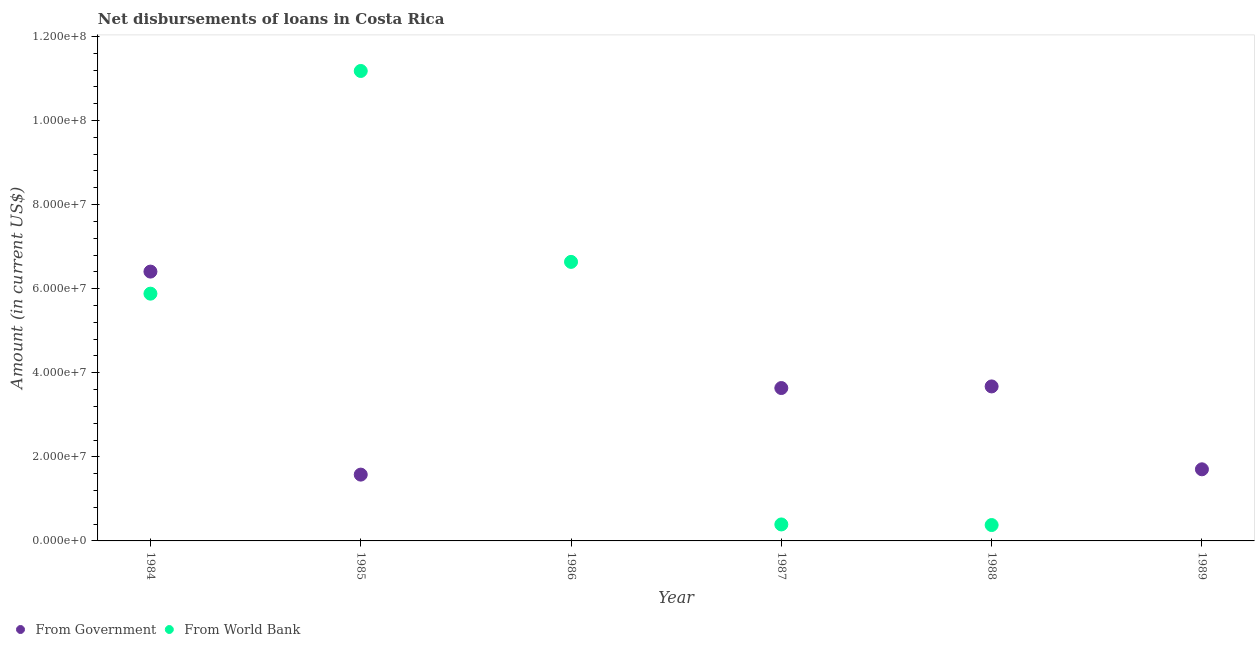What is the net disbursements of loan from government in 1987?
Provide a succinct answer. 3.64e+07. Across all years, what is the maximum net disbursements of loan from government?
Provide a short and direct response. 6.41e+07. Across all years, what is the minimum net disbursements of loan from government?
Make the answer very short. 0. What is the total net disbursements of loan from world bank in the graph?
Your answer should be compact. 2.45e+08. What is the difference between the net disbursements of loan from government in 1985 and that in 1989?
Keep it short and to the point. -1.26e+06. What is the difference between the net disbursements of loan from government in 1987 and the net disbursements of loan from world bank in 1984?
Ensure brevity in your answer.  -2.24e+07. What is the average net disbursements of loan from government per year?
Keep it short and to the point. 2.83e+07. In the year 1984, what is the difference between the net disbursements of loan from government and net disbursements of loan from world bank?
Give a very brief answer. 5.25e+06. In how many years, is the net disbursements of loan from world bank greater than 96000000 US$?
Your response must be concise. 1. What is the ratio of the net disbursements of loan from government in 1988 to that in 1989?
Give a very brief answer. 2.16. What is the difference between the highest and the second highest net disbursements of loan from world bank?
Make the answer very short. 4.54e+07. What is the difference between the highest and the lowest net disbursements of loan from government?
Your answer should be very brief. 6.41e+07. Does the net disbursements of loan from world bank monotonically increase over the years?
Make the answer very short. No. Is the net disbursements of loan from government strictly less than the net disbursements of loan from world bank over the years?
Offer a very short reply. No. What is the difference between two consecutive major ticks on the Y-axis?
Keep it short and to the point. 2.00e+07. Are the values on the major ticks of Y-axis written in scientific E-notation?
Give a very brief answer. Yes. Does the graph contain grids?
Make the answer very short. No. What is the title of the graph?
Your response must be concise. Net disbursements of loans in Costa Rica. What is the label or title of the X-axis?
Keep it short and to the point. Year. What is the Amount (in current US$) of From Government in 1984?
Your answer should be compact. 6.41e+07. What is the Amount (in current US$) of From World Bank in 1984?
Offer a very short reply. 5.88e+07. What is the Amount (in current US$) in From Government in 1985?
Your response must be concise. 1.58e+07. What is the Amount (in current US$) in From World Bank in 1985?
Provide a succinct answer. 1.12e+08. What is the Amount (in current US$) in From Government in 1986?
Your response must be concise. 0. What is the Amount (in current US$) in From World Bank in 1986?
Ensure brevity in your answer.  6.64e+07. What is the Amount (in current US$) in From Government in 1987?
Your response must be concise. 3.64e+07. What is the Amount (in current US$) in From World Bank in 1987?
Your answer should be compact. 3.92e+06. What is the Amount (in current US$) of From Government in 1988?
Your answer should be very brief. 3.68e+07. What is the Amount (in current US$) of From World Bank in 1988?
Your answer should be compact. 3.78e+06. What is the Amount (in current US$) of From Government in 1989?
Your answer should be compact. 1.70e+07. What is the Amount (in current US$) of From World Bank in 1989?
Keep it short and to the point. 0. Across all years, what is the maximum Amount (in current US$) of From Government?
Your answer should be very brief. 6.41e+07. Across all years, what is the maximum Amount (in current US$) of From World Bank?
Your answer should be very brief. 1.12e+08. Across all years, what is the minimum Amount (in current US$) of From Government?
Make the answer very short. 0. What is the total Amount (in current US$) in From Government in the graph?
Your answer should be very brief. 1.70e+08. What is the total Amount (in current US$) in From World Bank in the graph?
Ensure brevity in your answer.  2.45e+08. What is the difference between the Amount (in current US$) of From Government in 1984 and that in 1985?
Provide a succinct answer. 4.83e+07. What is the difference between the Amount (in current US$) in From World Bank in 1984 and that in 1985?
Provide a short and direct response. -5.30e+07. What is the difference between the Amount (in current US$) of From World Bank in 1984 and that in 1986?
Your answer should be very brief. -7.56e+06. What is the difference between the Amount (in current US$) in From Government in 1984 and that in 1987?
Your answer should be very brief. 2.77e+07. What is the difference between the Amount (in current US$) of From World Bank in 1984 and that in 1987?
Ensure brevity in your answer.  5.49e+07. What is the difference between the Amount (in current US$) of From Government in 1984 and that in 1988?
Provide a short and direct response. 2.73e+07. What is the difference between the Amount (in current US$) in From World Bank in 1984 and that in 1988?
Offer a terse response. 5.50e+07. What is the difference between the Amount (in current US$) in From Government in 1984 and that in 1989?
Offer a terse response. 4.70e+07. What is the difference between the Amount (in current US$) in From World Bank in 1985 and that in 1986?
Provide a short and direct response. 4.54e+07. What is the difference between the Amount (in current US$) in From Government in 1985 and that in 1987?
Your response must be concise. -2.06e+07. What is the difference between the Amount (in current US$) in From World Bank in 1985 and that in 1987?
Ensure brevity in your answer.  1.08e+08. What is the difference between the Amount (in current US$) in From Government in 1985 and that in 1988?
Provide a short and direct response. -2.10e+07. What is the difference between the Amount (in current US$) of From World Bank in 1985 and that in 1988?
Make the answer very short. 1.08e+08. What is the difference between the Amount (in current US$) of From Government in 1985 and that in 1989?
Make the answer very short. -1.26e+06. What is the difference between the Amount (in current US$) in From World Bank in 1986 and that in 1987?
Your answer should be compact. 6.25e+07. What is the difference between the Amount (in current US$) in From World Bank in 1986 and that in 1988?
Provide a succinct answer. 6.26e+07. What is the difference between the Amount (in current US$) of From Government in 1987 and that in 1988?
Your answer should be very brief. -3.85e+05. What is the difference between the Amount (in current US$) in From World Bank in 1987 and that in 1988?
Provide a short and direct response. 1.42e+05. What is the difference between the Amount (in current US$) in From Government in 1987 and that in 1989?
Your answer should be very brief. 1.93e+07. What is the difference between the Amount (in current US$) of From Government in 1988 and that in 1989?
Offer a terse response. 1.97e+07. What is the difference between the Amount (in current US$) of From Government in 1984 and the Amount (in current US$) of From World Bank in 1985?
Offer a terse response. -4.77e+07. What is the difference between the Amount (in current US$) of From Government in 1984 and the Amount (in current US$) of From World Bank in 1986?
Your response must be concise. -2.31e+06. What is the difference between the Amount (in current US$) of From Government in 1984 and the Amount (in current US$) of From World Bank in 1987?
Your answer should be very brief. 6.01e+07. What is the difference between the Amount (in current US$) in From Government in 1984 and the Amount (in current US$) in From World Bank in 1988?
Ensure brevity in your answer.  6.03e+07. What is the difference between the Amount (in current US$) of From Government in 1985 and the Amount (in current US$) of From World Bank in 1986?
Your answer should be compact. -5.06e+07. What is the difference between the Amount (in current US$) in From Government in 1985 and the Amount (in current US$) in From World Bank in 1987?
Provide a succinct answer. 1.19e+07. What is the difference between the Amount (in current US$) of From Government in 1985 and the Amount (in current US$) of From World Bank in 1988?
Make the answer very short. 1.20e+07. What is the difference between the Amount (in current US$) in From Government in 1987 and the Amount (in current US$) in From World Bank in 1988?
Offer a terse response. 3.26e+07. What is the average Amount (in current US$) in From Government per year?
Your response must be concise. 2.83e+07. What is the average Amount (in current US$) in From World Bank per year?
Your answer should be compact. 4.08e+07. In the year 1984, what is the difference between the Amount (in current US$) of From Government and Amount (in current US$) of From World Bank?
Provide a short and direct response. 5.25e+06. In the year 1985, what is the difference between the Amount (in current US$) of From Government and Amount (in current US$) of From World Bank?
Your answer should be very brief. -9.60e+07. In the year 1987, what is the difference between the Amount (in current US$) of From Government and Amount (in current US$) of From World Bank?
Your answer should be very brief. 3.24e+07. In the year 1988, what is the difference between the Amount (in current US$) in From Government and Amount (in current US$) in From World Bank?
Make the answer very short. 3.30e+07. What is the ratio of the Amount (in current US$) in From Government in 1984 to that in 1985?
Keep it short and to the point. 4.06. What is the ratio of the Amount (in current US$) of From World Bank in 1984 to that in 1985?
Offer a terse response. 0.53. What is the ratio of the Amount (in current US$) in From World Bank in 1984 to that in 1986?
Make the answer very short. 0.89. What is the ratio of the Amount (in current US$) in From Government in 1984 to that in 1987?
Offer a very short reply. 1.76. What is the ratio of the Amount (in current US$) of From World Bank in 1984 to that in 1987?
Provide a short and direct response. 15. What is the ratio of the Amount (in current US$) of From Government in 1984 to that in 1988?
Give a very brief answer. 1.74. What is the ratio of the Amount (in current US$) of From World Bank in 1984 to that in 1988?
Your answer should be compact. 15.57. What is the ratio of the Amount (in current US$) in From Government in 1984 to that in 1989?
Provide a succinct answer. 3.76. What is the ratio of the Amount (in current US$) in From World Bank in 1985 to that in 1986?
Provide a short and direct response. 1.68. What is the ratio of the Amount (in current US$) in From Government in 1985 to that in 1987?
Your answer should be very brief. 0.43. What is the ratio of the Amount (in current US$) of From World Bank in 1985 to that in 1987?
Your answer should be compact. 28.52. What is the ratio of the Amount (in current US$) of From Government in 1985 to that in 1988?
Ensure brevity in your answer.  0.43. What is the ratio of the Amount (in current US$) of From World Bank in 1985 to that in 1988?
Your response must be concise. 29.59. What is the ratio of the Amount (in current US$) of From Government in 1985 to that in 1989?
Give a very brief answer. 0.93. What is the ratio of the Amount (in current US$) in From World Bank in 1986 to that in 1987?
Provide a succinct answer. 16.93. What is the ratio of the Amount (in current US$) of From World Bank in 1986 to that in 1988?
Provide a short and direct response. 17.57. What is the ratio of the Amount (in current US$) of From Government in 1987 to that in 1988?
Make the answer very short. 0.99. What is the ratio of the Amount (in current US$) in From World Bank in 1987 to that in 1988?
Your answer should be very brief. 1.04. What is the ratio of the Amount (in current US$) of From Government in 1987 to that in 1989?
Your answer should be very brief. 2.13. What is the ratio of the Amount (in current US$) of From Government in 1988 to that in 1989?
Offer a terse response. 2.16. What is the difference between the highest and the second highest Amount (in current US$) of From Government?
Provide a succinct answer. 2.73e+07. What is the difference between the highest and the second highest Amount (in current US$) of From World Bank?
Keep it short and to the point. 4.54e+07. What is the difference between the highest and the lowest Amount (in current US$) of From Government?
Provide a short and direct response. 6.41e+07. What is the difference between the highest and the lowest Amount (in current US$) in From World Bank?
Your answer should be compact. 1.12e+08. 